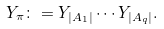Convert formula to latex. <formula><loc_0><loc_0><loc_500><loc_500>Y _ { \pi } \colon = Y _ { | A _ { 1 } | } \cdots Y _ { | A _ { q } | } .</formula> 